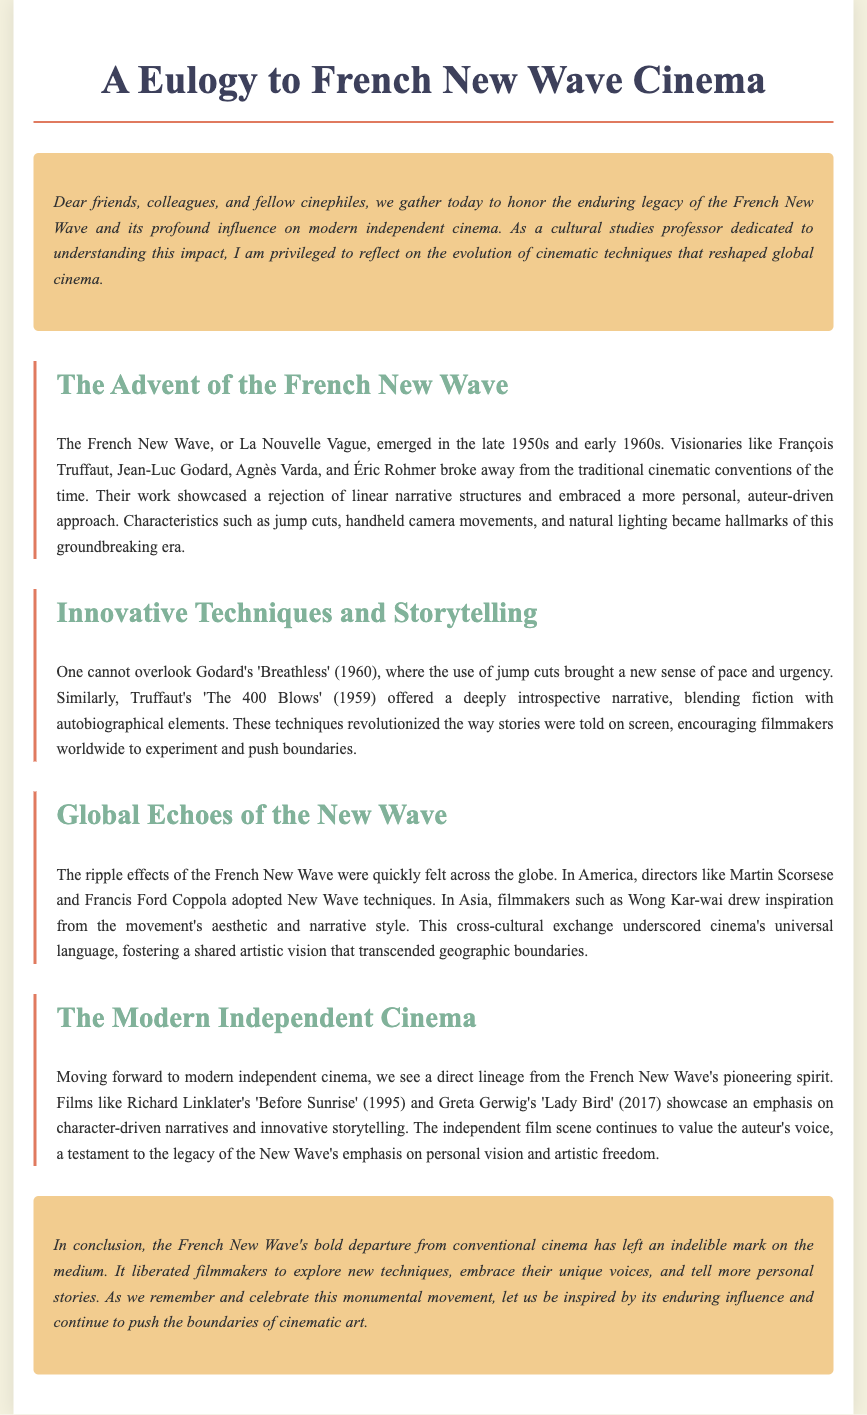What is the term used for the French New Wave? The document refers to the French New Wave as La Nouvelle Vague.
Answer: La Nouvelle Vague Who are some key figures of the French New Wave mentioned in the document? The document lists François Truffaut, Jean-Luc Godard, Agnès Varda, and Éric Rohmer as key figures.
Answer: François Truffaut, Jean-Luc Godard, Agnès Varda, Éric Rohmer What innovative technique did Godard utilize in 'Breathless'? The document states that Godard used jump cuts, which brought a new sense of pace and urgency.
Answer: Jump cuts Which film is cited as an example of a deeply introspective narrative? The document mentions 'The 400 Blows' (1959) as an example blending fiction with autobiographical elements.
Answer: The 400 Blows Which director's film features an emphasis on character-driven narratives as noted in the document? The document cites Richard Linklater's 'Before Sunrise' (1995) as a film that emphasizes character-driven narratives.
Answer: Before Sunrise What commonality do modern independent films share with French New Wave cinema? The document highlights that modern independent cinema values the auteur's voice, a testament to the New Wave’s legacy.
Answer: Auteur's voice Which award-winning director referenced in the document created 'Lady Bird'? The document notes that Greta Gerwig directed 'Lady Bird' (2017).
Answer: Greta Gerwig What year did the French New Wave emerge? The document states the French New Wave emerged in the late 1950s and early 1960s.
Answer: Late 1950s and early 1960s How did the French New Wave influence global filmmakers? The document indicates that the ripple effects influenced filmmakers like Martin Scorsese and Francis Ford Coppola in America.
Answer: Martin Scorsese and Francis Ford Coppola 